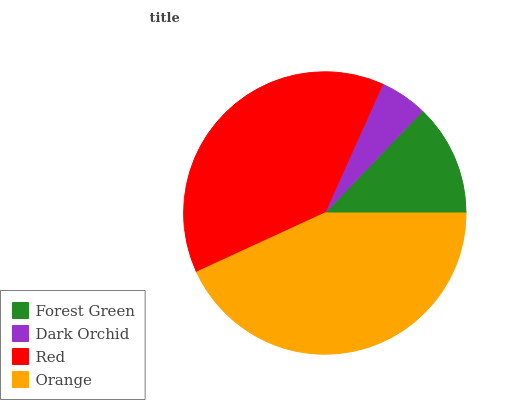Is Dark Orchid the minimum?
Answer yes or no. Yes. Is Orange the maximum?
Answer yes or no. Yes. Is Red the minimum?
Answer yes or no. No. Is Red the maximum?
Answer yes or no. No. Is Red greater than Dark Orchid?
Answer yes or no. Yes. Is Dark Orchid less than Red?
Answer yes or no. Yes. Is Dark Orchid greater than Red?
Answer yes or no. No. Is Red less than Dark Orchid?
Answer yes or no. No. Is Red the high median?
Answer yes or no. Yes. Is Forest Green the low median?
Answer yes or no. Yes. Is Forest Green the high median?
Answer yes or no. No. Is Orange the low median?
Answer yes or no. No. 